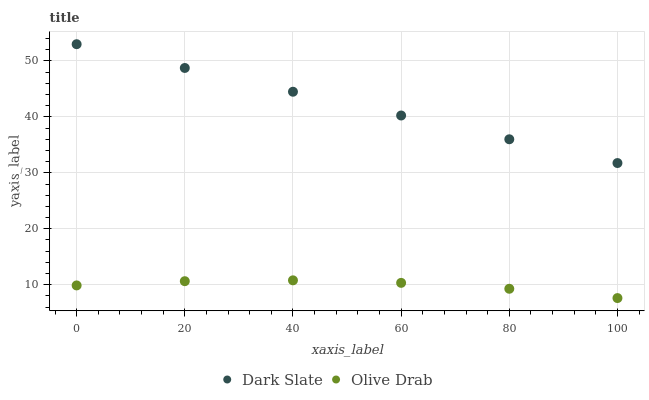Does Olive Drab have the minimum area under the curve?
Answer yes or no. Yes. Does Dark Slate have the maximum area under the curve?
Answer yes or no. Yes. Does Olive Drab have the maximum area under the curve?
Answer yes or no. No. Is Dark Slate the smoothest?
Answer yes or no. Yes. Is Olive Drab the roughest?
Answer yes or no. Yes. Is Olive Drab the smoothest?
Answer yes or no. No. Does Olive Drab have the lowest value?
Answer yes or no. Yes. Does Dark Slate have the highest value?
Answer yes or no. Yes. Does Olive Drab have the highest value?
Answer yes or no. No. Is Olive Drab less than Dark Slate?
Answer yes or no. Yes. Is Dark Slate greater than Olive Drab?
Answer yes or no. Yes. Does Olive Drab intersect Dark Slate?
Answer yes or no. No. 